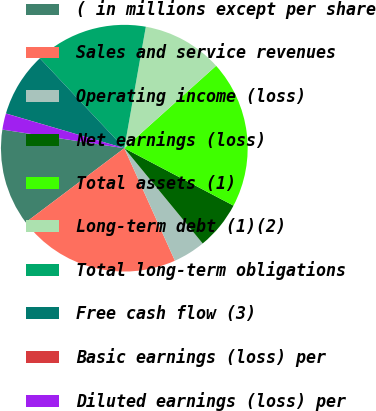Convert chart to OTSL. <chart><loc_0><loc_0><loc_500><loc_500><pie_chart><fcel>( in millions except per share<fcel>Sales and service revenues<fcel>Operating income (loss)<fcel>Net earnings (loss)<fcel>Total assets (1)<fcel>Long-term debt (1)(2)<fcel>Total long-term obligations<fcel>Free cash flow (3)<fcel>Basic earnings (loss) per<fcel>Diluted earnings (loss) per<nl><fcel>12.68%<fcel>21.46%<fcel>4.23%<fcel>6.34%<fcel>19.35%<fcel>10.57%<fcel>14.79%<fcel>8.46%<fcel>0.01%<fcel>2.12%<nl></chart> 